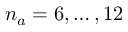<formula> <loc_0><loc_0><loc_500><loc_500>n _ { a } = 6 , \dots , 1 2</formula> 